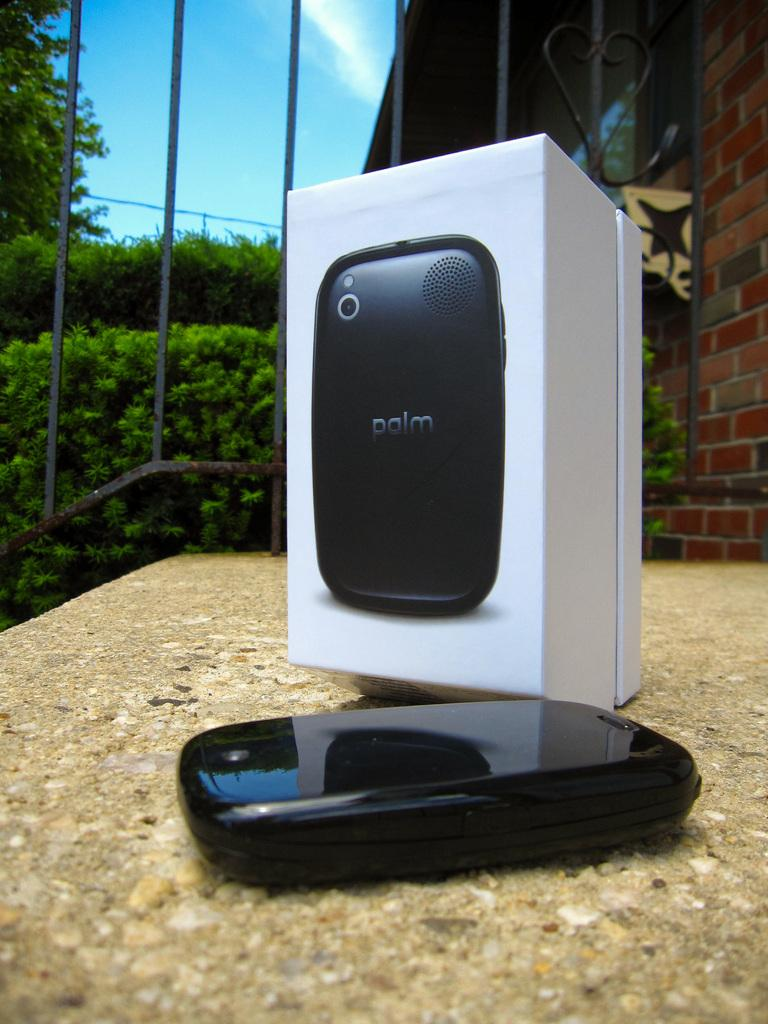<image>
Render a clear and concise summary of the photo. A black phone, marked palm, is laying in front of its box. 